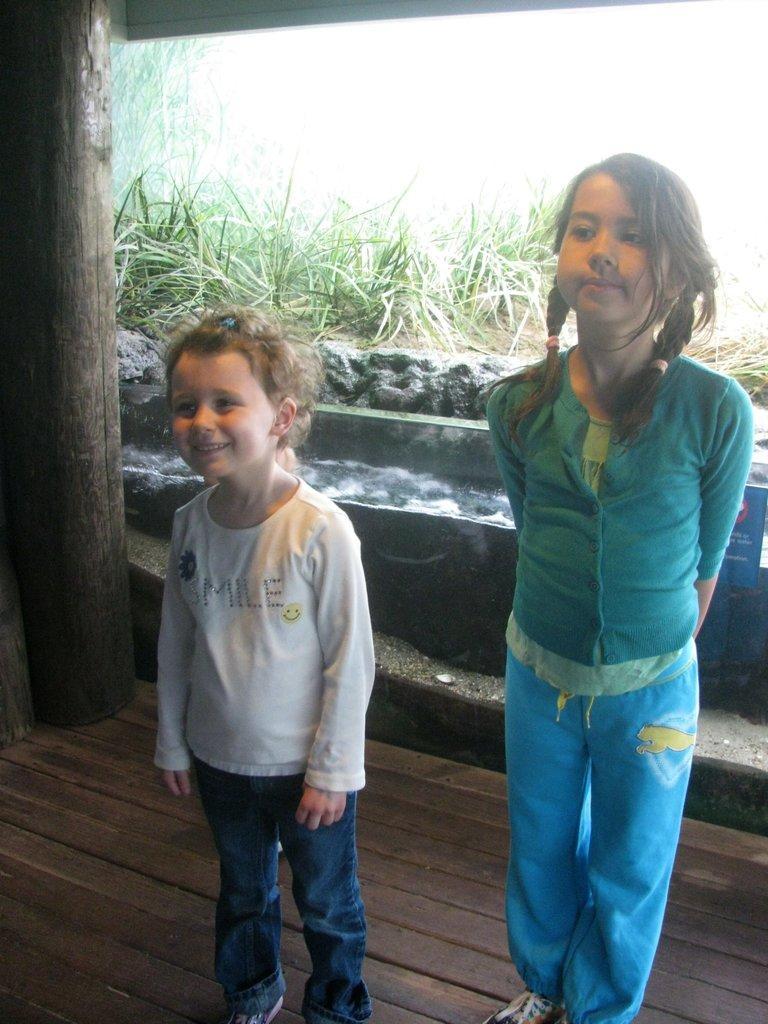Please provide a concise description of this image. In this picture I can see couple of girls standing and I can see plants in the back. 